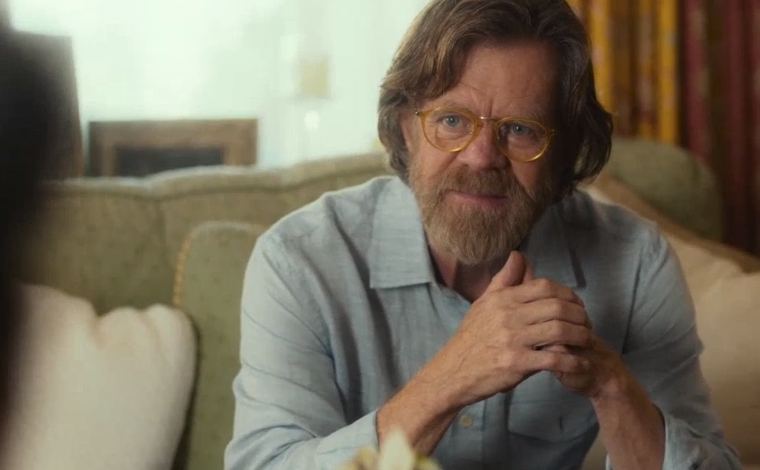Explain the visual content of the image in great detail. The image features a middle-aged man with a beard and glasses, sitting on a beige armchair. He is dressed in a casual blue denim shirt with the sleeves rolled up to his elbows. The man is clasping his hands together and seems to be engaged in a thoughtful conversation or lost in thought, judging by his focused, yet slightly concerned facial expression. He looks directly towards something or someone off-camera, suggesting an interaction or contemplation. The background is softly blurred but shows hints of a domestic setting with warm lighting, possibly a living room with muted and neutral tones. 